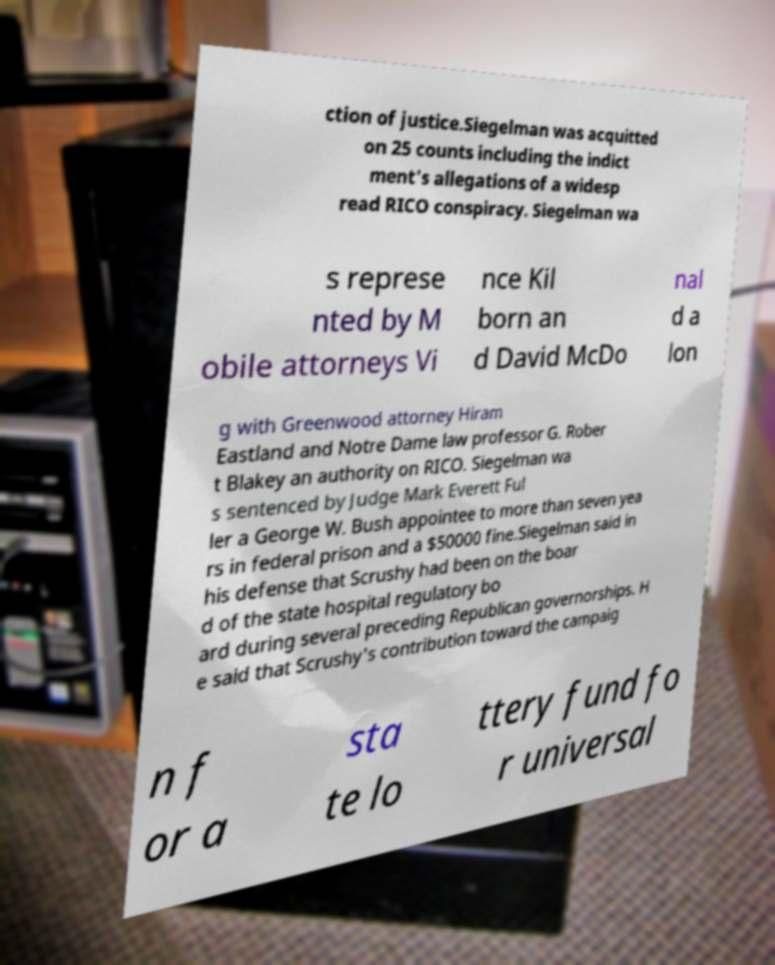Can you read and provide the text displayed in the image?This photo seems to have some interesting text. Can you extract and type it out for me? ction of justice.Siegelman was acquitted on 25 counts including the indict ment's allegations of a widesp read RICO conspiracy. Siegelman wa s represe nted by M obile attorneys Vi nce Kil born an d David McDo nal d a lon g with Greenwood attorney Hiram Eastland and Notre Dame law professor G. Rober t Blakey an authority on RICO. Siegelman wa s sentenced by Judge Mark Everett Ful ler a George W. Bush appointee to more than seven yea rs in federal prison and a $50000 fine.Siegelman said in his defense that Scrushy had been on the boar d of the state hospital regulatory bo ard during several preceding Republican governorships. H e said that Scrushy's contribution toward the campaig n f or a sta te lo ttery fund fo r universal 